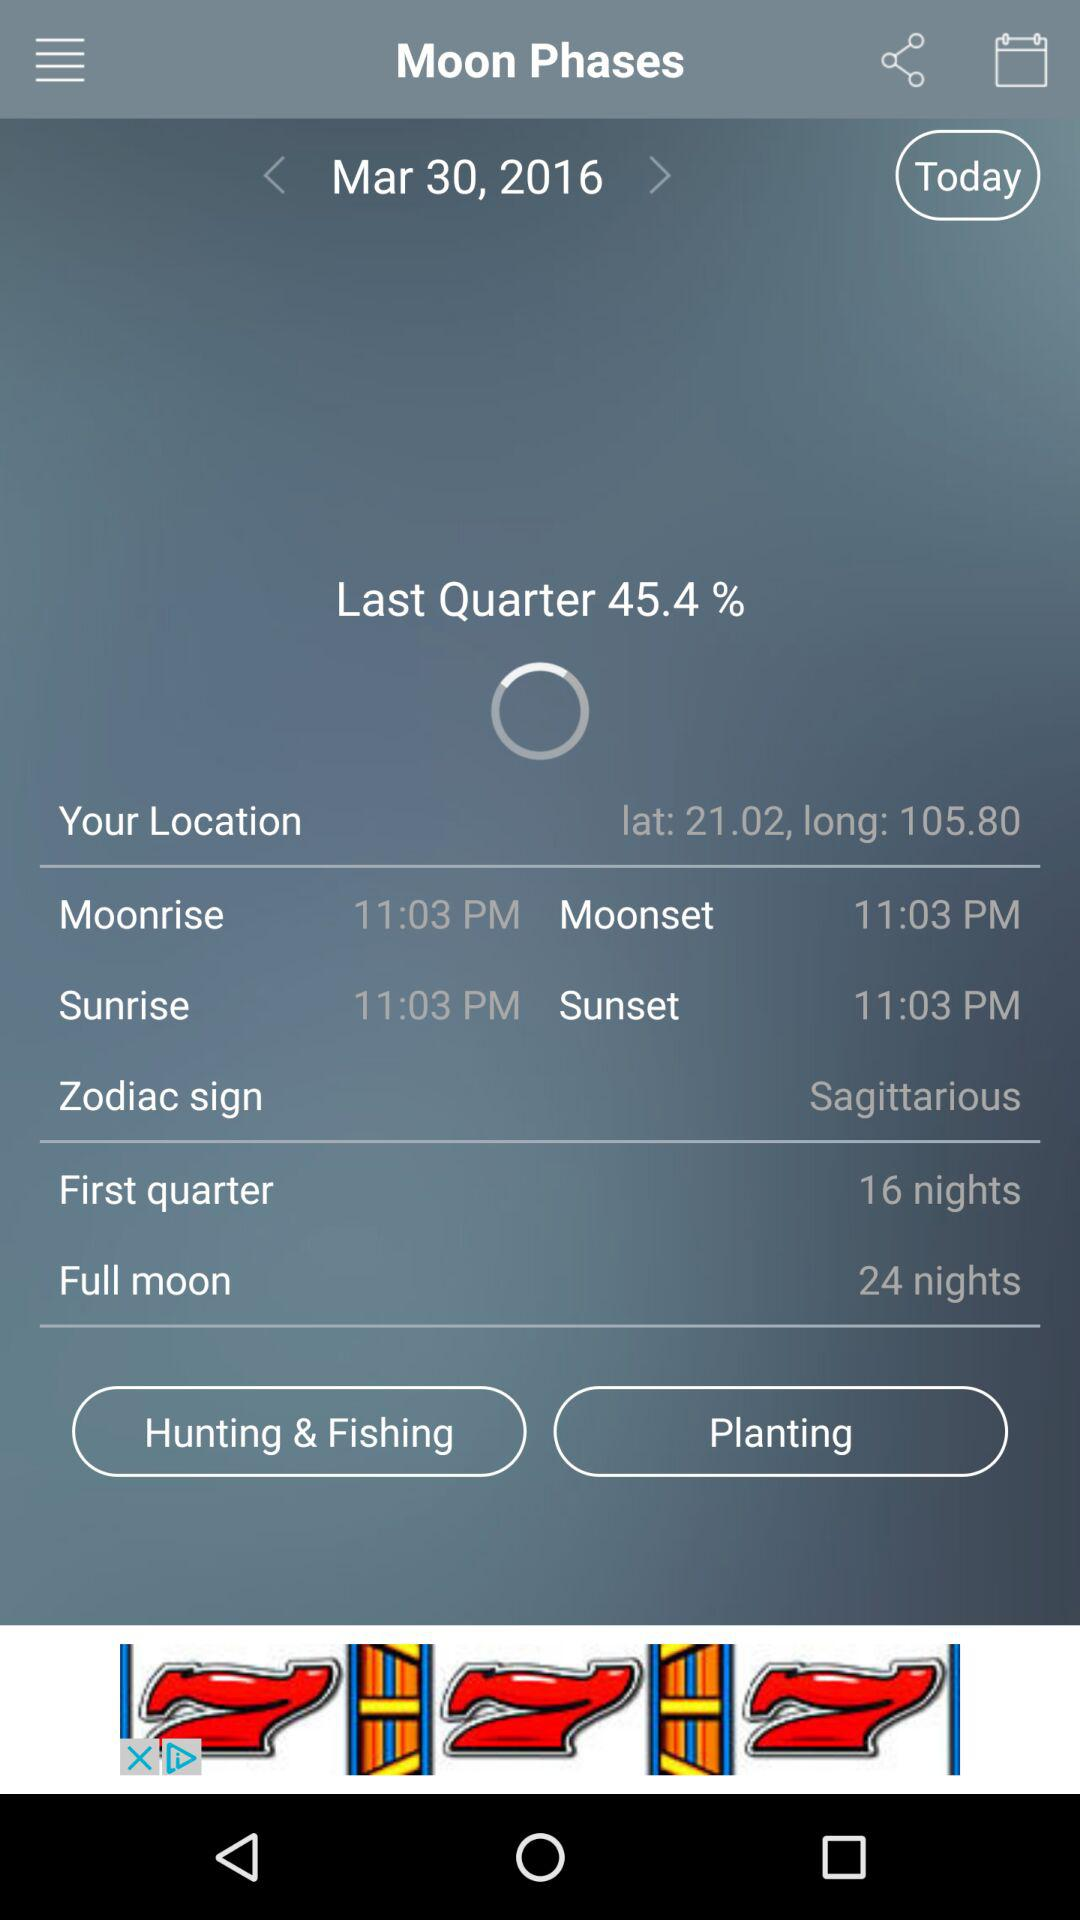What is the date? The date is Mar 30, 2016. 